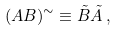Convert formula to latex. <formula><loc_0><loc_0><loc_500><loc_500>( A B ) ^ { \sim } \equiv \tilde { B } \tilde { A } \, ,</formula> 